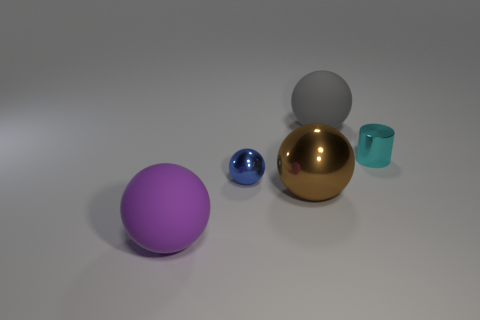Subtract all tiny spheres. How many spheres are left? 3 Add 5 small cyan rubber balls. How many objects exist? 10 Subtract all brown spheres. How many spheres are left? 3 Subtract 2 spheres. How many spheres are left? 2 Add 5 gray metal balls. How many gray metal balls exist? 5 Subtract 0 yellow cylinders. How many objects are left? 5 Subtract all cylinders. How many objects are left? 4 Subtract all red spheres. Subtract all gray cubes. How many spheres are left? 4 Subtract all blue cylinders. How many purple balls are left? 1 Subtract all gray spheres. Subtract all big things. How many objects are left? 1 